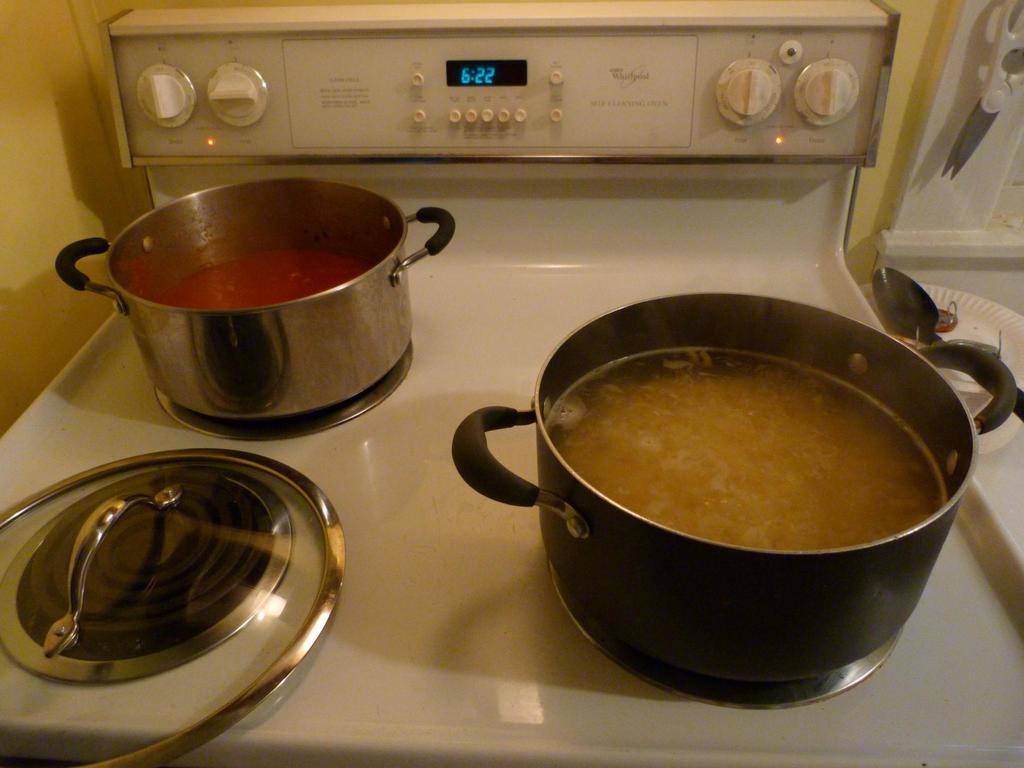What time does the stove say?
Ensure brevity in your answer.  6:22. What is the brand of this stove?
Offer a terse response. Whirlpool. 